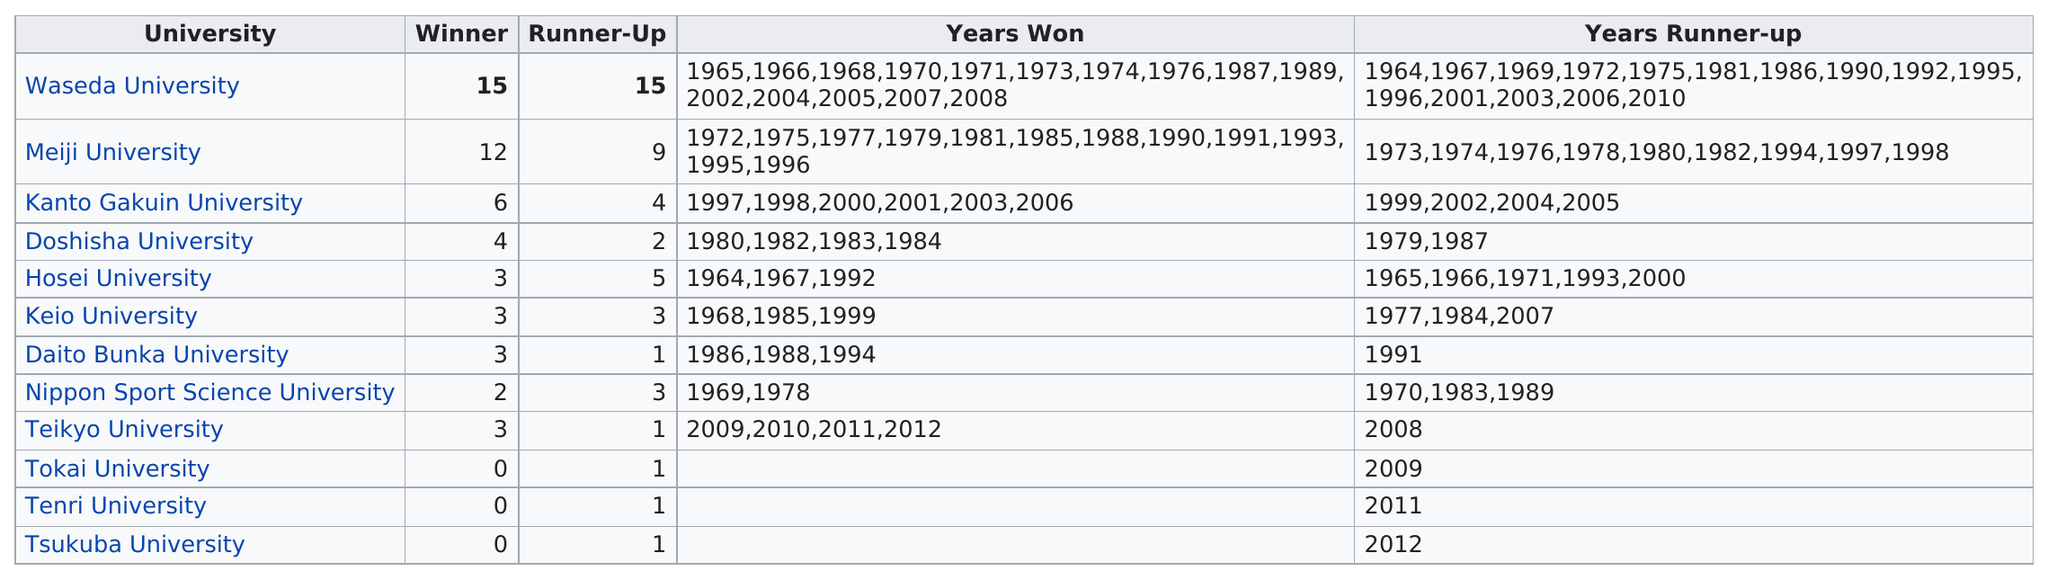Indicate a few pertinent items in this graphic. Nippon Sport Science University has won a total of two championships. Waseda University has the most years of winning. Waseda University has the most rugby championships out of all universities. Of the teams in question, Tokai University, Tenri University, and Tsukuba University have yet to secure a win. In 1964, Hosei University won the National High School Baseball Championship. The next year, Waseda University won the championship. 